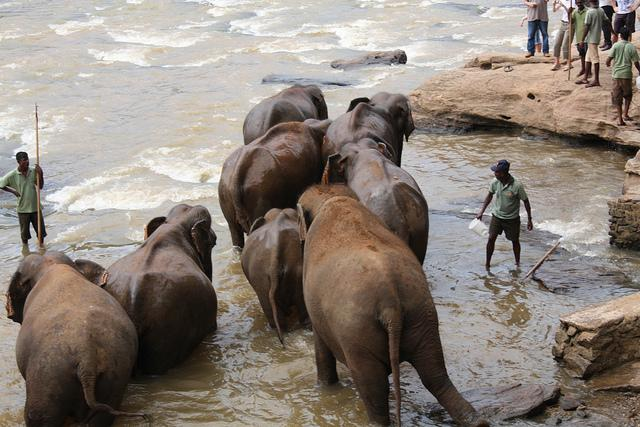Why is the person on the right of the elephants holding a bucket?

Choices:
A) catch spit
B) throw mud
C) help wash
D) catch poop help wash 